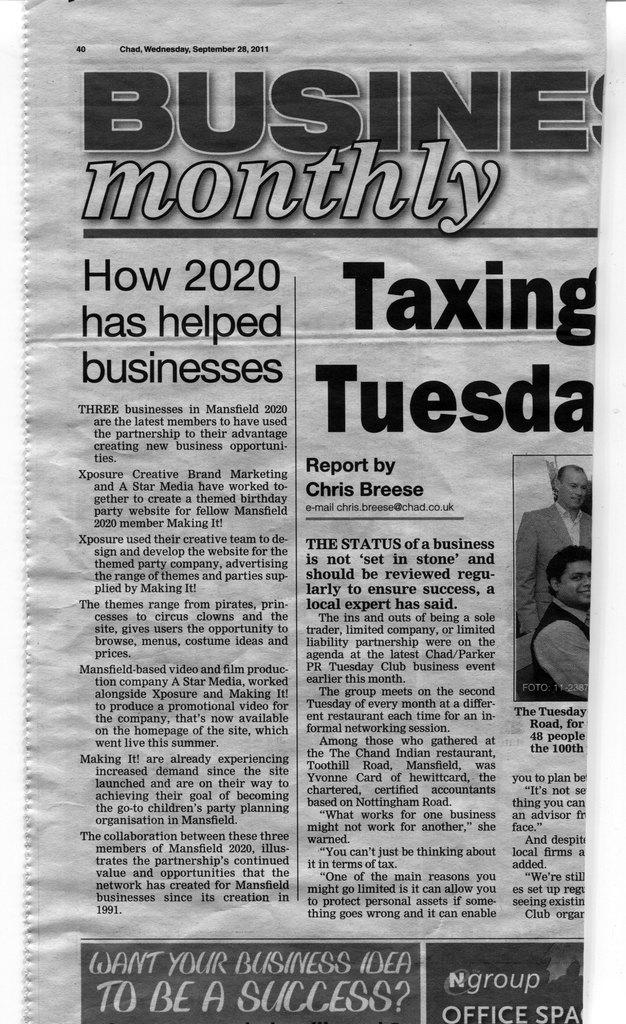What is the main subject of the image? The main subject of the image is an article. Are there any illustrations or depictions in the article? Yes, there are depictions of people in the image. What type of information can be found in the image? There is some information present in the image. What type of church is depicted in the image? There is no church depicted in the image; it features an article with depictions of people and information. 